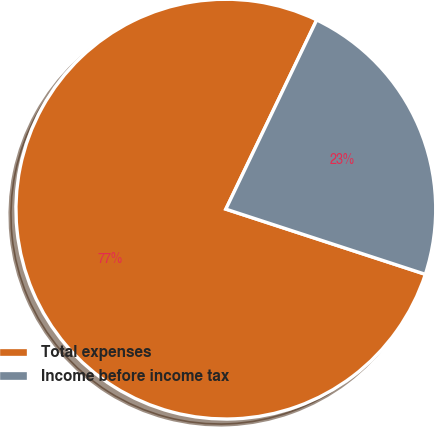<chart> <loc_0><loc_0><loc_500><loc_500><pie_chart><fcel>Total expenses<fcel>Income before income tax<nl><fcel>77.1%<fcel>22.9%<nl></chart> 